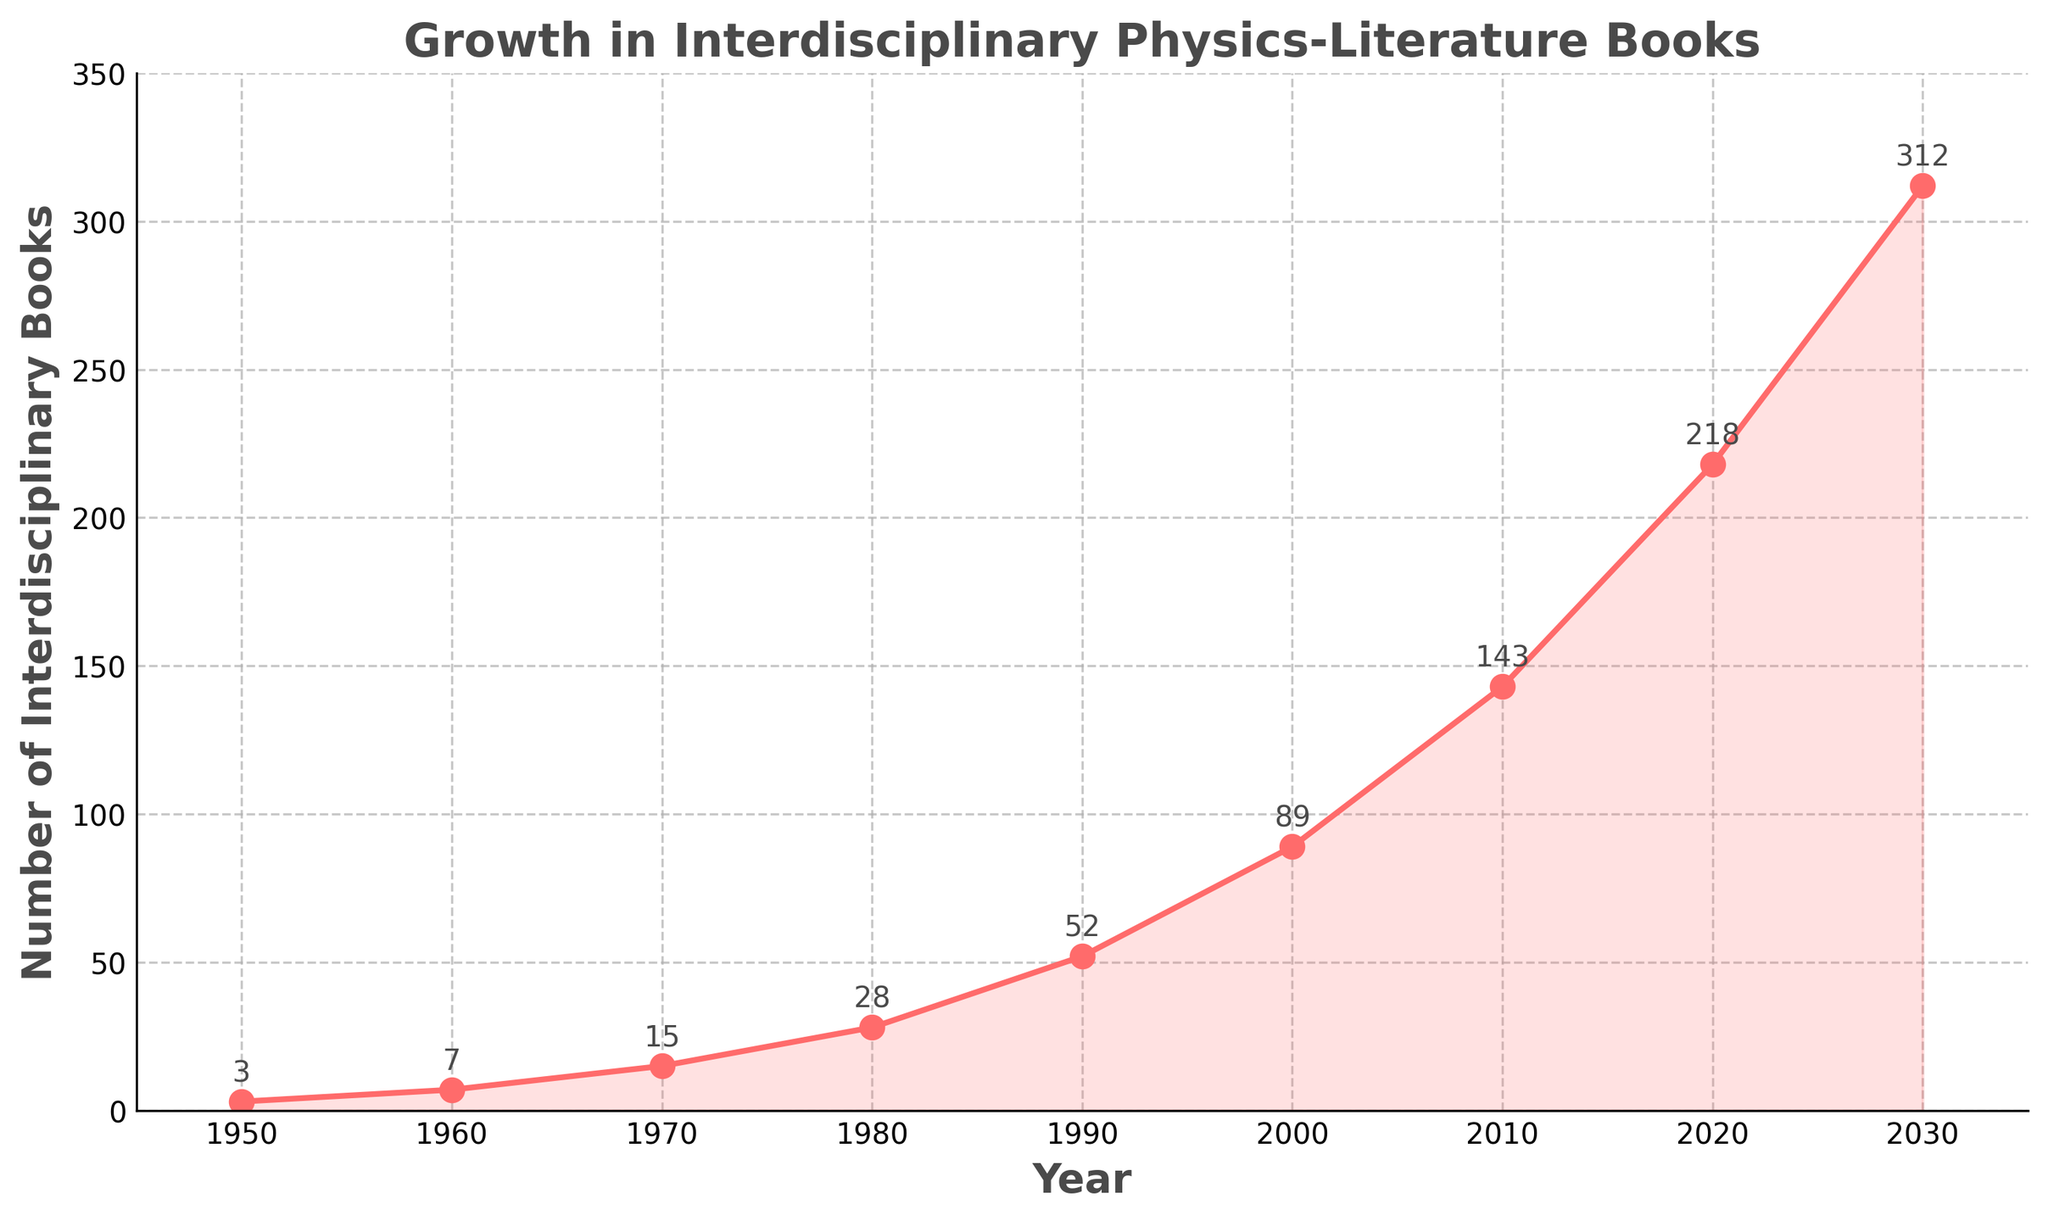What's the total number of interdisciplinary books from 1950 to 2000? Look at the data for the years 1950, 1960, 1970, 1980, 1990, and 2000. Add the values: 3 + 7 + 15 + 28 + 52 + 89 = 194
Answer: 194 Which decade saw the highest growth in the number of interdisciplinary books? Calculate the difference in the number of books between consecutive decades. The differences are: 1960-1950: 4, 1970-1960: 8, 1980-1970: 13, 1990-1980: 24, 2000-1990: 37, 2010-2000: 54, 2020-2010: 75, 2030-2020: 94. The highest difference is 94 in the decade 2020 to 2030
Answer: 2020 to 2030 What is the average number of interdisciplinary books per decade from 1950 to 2030? There are 9 decades. The sum of all books is: 3 + 7 + 15 + 28 + 52 + 89 + 143 + 218 + 312 = 867. The average is 867 / 9 ≈ 96.33
Answer: 96.33 In which year did the number of interdisciplinary books first exceed 100? By examining the data, the first year when the number exceeded 100 was 2010 with 143 books
Answer: 2010 Compare the number of interdisciplinary books in 1980 and 2030. Which year had more, and by how much? 1980 had 28 books, and 2030 had 312 books. The difference is 312 - 28 = 284. Therefore, 2030 had more books by 284
Answer: 2030 by 284 How many more interdisciplinary books were there in 2020 compared to 1950? In 1950, there were 3 books, and in 2020, there were 218 books. The difference is 218 - 3 = 215
Answer: 215 What is the range of the number of interdisciplinary books from 1950 to 2030? The range is the difference between the highest and lowest values: 312 (in 2030) - 3 (in 1950) = 309
Answer: 309 What is the median number of interdisciplinary books for the given years? The years are 1950, 1960, 1970, 1980, 1990, 2000, 2010, 2020, and 2030. The corresponding books are: 3, 7, 15, 28, 52, 89, 143, 218, and 312. The median is the middle value in the ordered list, which is 52
Answer: 52 